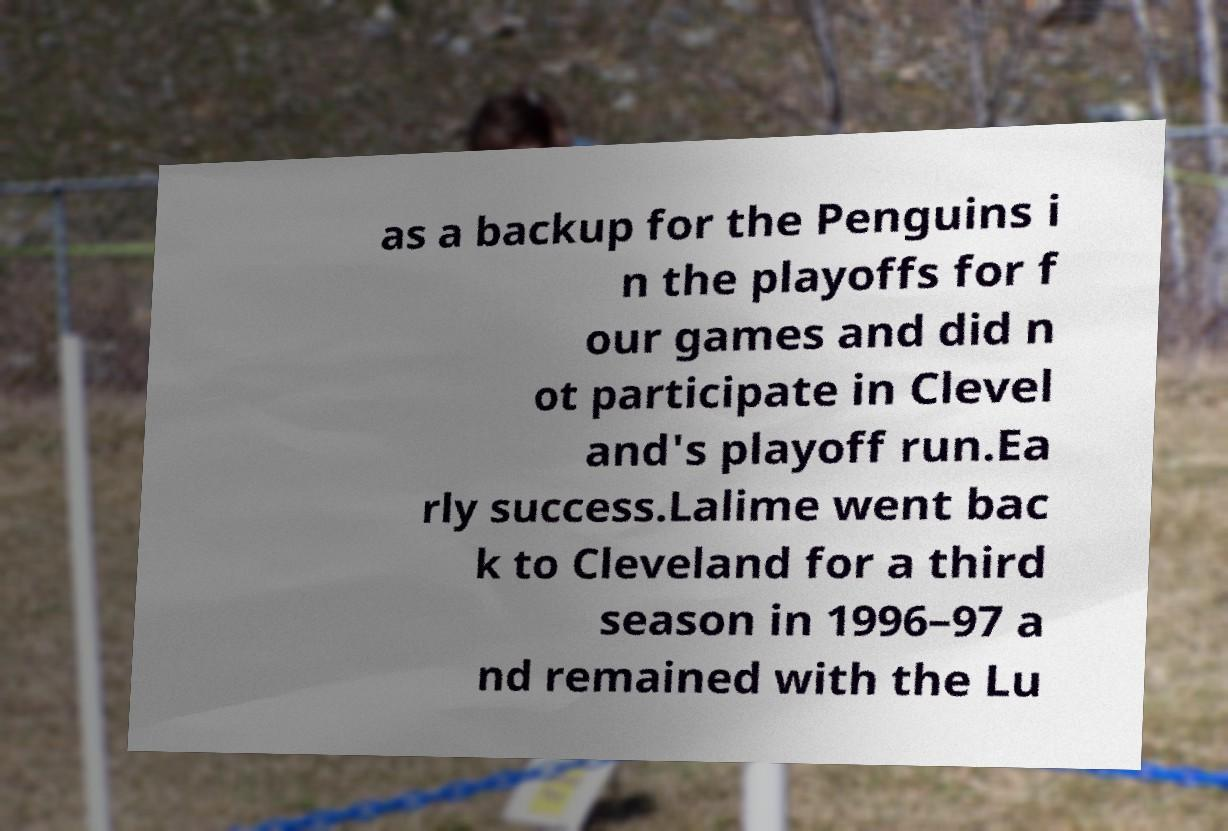Please identify and transcribe the text found in this image. as a backup for the Penguins i n the playoffs for f our games and did n ot participate in Clevel and's playoff run.Ea rly success.Lalime went bac k to Cleveland for a third season in 1996–97 a nd remained with the Lu 